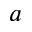<formula> <loc_0><loc_0><loc_500><loc_500>a</formula> 